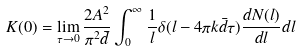Convert formula to latex. <formula><loc_0><loc_0><loc_500><loc_500>K ( 0 ) = \lim _ { \tau \to 0 } \frac { 2 A ^ { 2 } } { \pi ^ { 2 } \bar { d } } \int _ { 0 } ^ { \infty } \frac { 1 } { l } \delta ( l - 4 \pi k \bar { d } \tau ) \frac { d N ( l ) } { d l } d l</formula> 